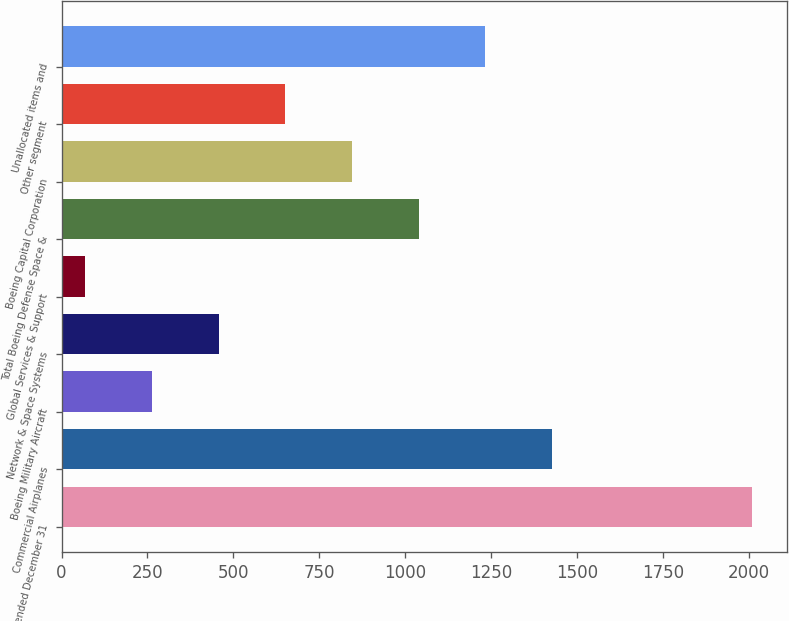Convert chart to OTSL. <chart><loc_0><loc_0><loc_500><loc_500><bar_chart><fcel>Years ended December 31<fcel>Commercial Airplanes<fcel>Boeing Military Aircraft<fcel>Network & Space Systems<fcel>Global Services & Support<fcel>Total Boeing Defense Space &<fcel>Boeing Capital Corporation<fcel>Other segment<fcel>Unallocated items and<nl><fcel>2009<fcel>1427<fcel>263<fcel>457<fcel>69<fcel>1039<fcel>845<fcel>651<fcel>1233<nl></chart> 